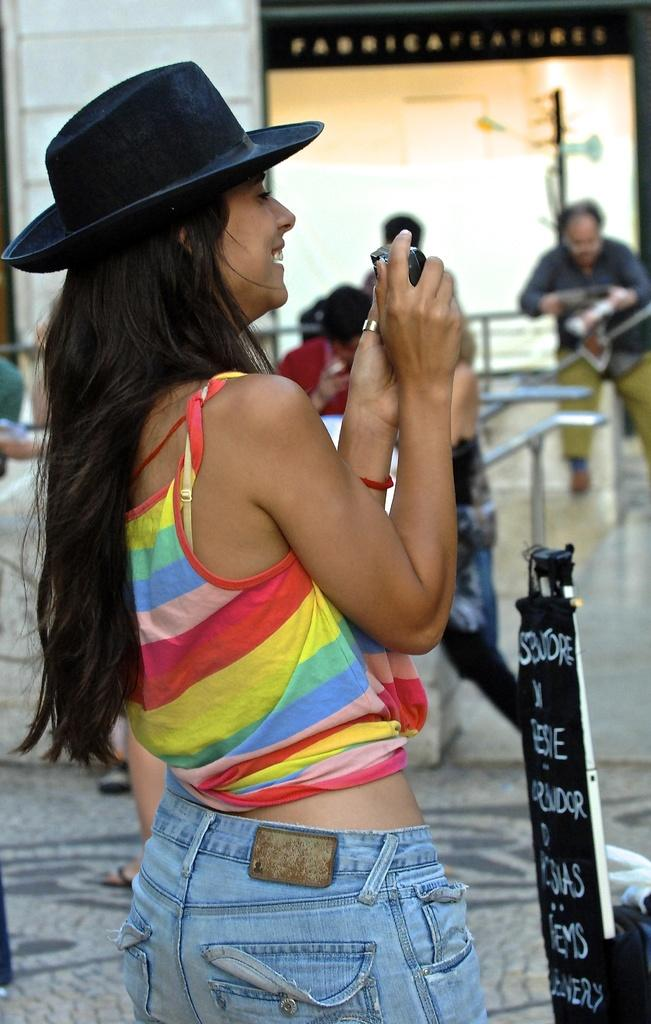Who is the main subject in the image? There is a woman in the image. What is the woman wearing on her head? The woman is wearing a hat. What is the woman holding in her hands? The woman is holding a camera. What can be seen in the background of the image? There is a board, a group of people, a house, and iron rods in the background of the image. What type of lamp can be seen on the woman's hat in the image? There is no lamp present on the woman's hat in the image. What kind of flesh is visible on the woman's face in the image? The image does not show any flesh on the woman's face, as it is a photograph and not a physical representation. 